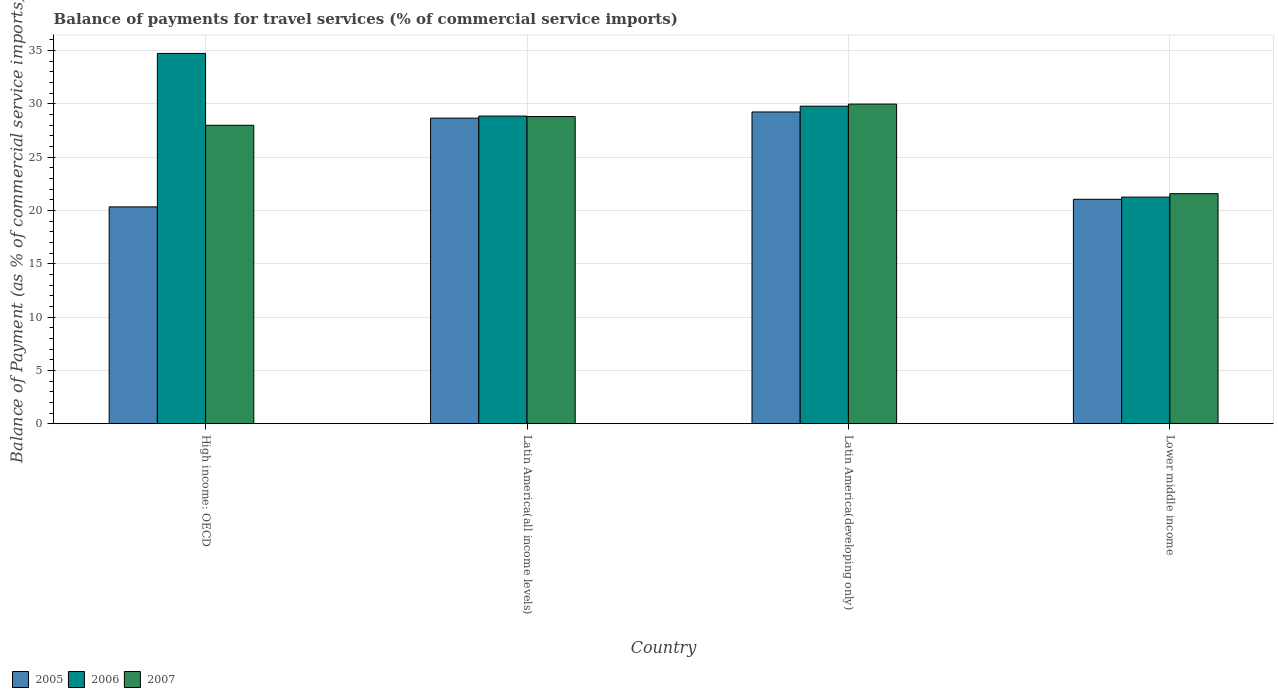How many different coloured bars are there?
Ensure brevity in your answer.  3. How many groups of bars are there?
Provide a succinct answer. 4. Are the number of bars per tick equal to the number of legend labels?
Make the answer very short. Yes. Are the number of bars on each tick of the X-axis equal?
Your answer should be compact. Yes. What is the label of the 4th group of bars from the left?
Provide a short and direct response. Lower middle income. In how many cases, is the number of bars for a given country not equal to the number of legend labels?
Your response must be concise. 0. What is the balance of payments for travel services in 2006 in Lower middle income?
Make the answer very short. 21.25. Across all countries, what is the maximum balance of payments for travel services in 2005?
Offer a terse response. 29.23. Across all countries, what is the minimum balance of payments for travel services in 2007?
Your answer should be very brief. 21.57. In which country was the balance of payments for travel services in 2006 maximum?
Make the answer very short. High income: OECD. In which country was the balance of payments for travel services in 2006 minimum?
Offer a terse response. Lower middle income. What is the total balance of payments for travel services in 2006 in the graph?
Provide a succinct answer. 114.58. What is the difference between the balance of payments for travel services in 2007 in High income: OECD and that in Latin America(all income levels)?
Give a very brief answer. -0.82. What is the difference between the balance of payments for travel services in 2007 in High income: OECD and the balance of payments for travel services in 2005 in Latin America(all income levels)?
Provide a succinct answer. -0.67. What is the average balance of payments for travel services in 2007 per country?
Make the answer very short. 27.08. What is the difference between the balance of payments for travel services of/in 2007 and balance of payments for travel services of/in 2005 in High income: OECD?
Make the answer very short. 7.65. In how many countries, is the balance of payments for travel services in 2006 greater than 35 %?
Provide a succinct answer. 0. What is the ratio of the balance of payments for travel services in 2007 in Latin America(all income levels) to that in Latin America(developing only)?
Make the answer very short. 0.96. Is the difference between the balance of payments for travel services in 2007 in Latin America(all income levels) and Lower middle income greater than the difference between the balance of payments for travel services in 2005 in Latin America(all income levels) and Lower middle income?
Keep it short and to the point. No. What is the difference between the highest and the second highest balance of payments for travel services in 2007?
Offer a terse response. -0.82. What is the difference between the highest and the lowest balance of payments for travel services in 2007?
Give a very brief answer. 8.4. What does the 1st bar from the right in High income: OECD represents?
Give a very brief answer. 2007. How many countries are there in the graph?
Ensure brevity in your answer.  4. What is the difference between two consecutive major ticks on the Y-axis?
Your response must be concise. 5. Are the values on the major ticks of Y-axis written in scientific E-notation?
Keep it short and to the point. No. Where does the legend appear in the graph?
Your response must be concise. Bottom left. How many legend labels are there?
Provide a short and direct response. 3. What is the title of the graph?
Your answer should be compact. Balance of payments for travel services (% of commercial service imports). What is the label or title of the X-axis?
Ensure brevity in your answer.  Country. What is the label or title of the Y-axis?
Provide a short and direct response. Balance of Payment (as % of commercial service imports). What is the Balance of Payment (as % of commercial service imports) in 2005 in High income: OECD?
Provide a succinct answer. 20.33. What is the Balance of Payment (as % of commercial service imports) in 2006 in High income: OECD?
Provide a short and direct response. 34.72. What is the Balance of Payment (as % of commercial service imports) in 2007 in High income: OECD?
Provide a short and direct response. 27.98. What is the Balance of Payment (as % of commercial service imports) in 2005 in Latin America(all income levels)?
Your answer should be compact. 28.65. What is the Balance of Payment (as % of commercial service imports) in 2006 in Latin America(all income levels)?
Your answer should be very brief. 28.84. What is the Balance of Payment (as % of commercial service imports) in 2007 in Latin America(all income levels)?
Offer a terse response. 28.8. What is the Balance of Payment (as % of commercial service imports) in 2005 in Latin America(developing only)?
Provide a succinct answer. 29.23. What is the Balance of Payment (as % of commercial service imports) of 2006 in Latin America(developing only)?
Ensure brevity in your answer.  29.77. What is the Balance of Payment (as % of commercial service imports) of 2007 in Latin America(developing only)?
Keep it short and to the point. 29.97. What is the Balance of Payment (as % of commercial service imports) in 2005 in Lower middle income?
Offer a terse response. 21.04. What is the Balance of Payment (as % of commercial service imports) of 2006 in Lower middle income?
Your answer should be very brief. 21.25. What is the Balance of Payment (as % of commercial service imports) of 2007 in Lower middle income?
Provide a succinct answer. 21.57. Across all countries, what is the maximum Balance of Payment (as % of commercial service imports) in 2005?
Offer a very short reply. 29.23. Across all countries, what is the maximum Balance of Payment (as % of commercial service imports) in 2006?
Give a very brief answer. 34.72. Across all countries, what is the maximum Balance of Payment (as % of commercial service imports) of 2007?
Ensure brevity in your answer.  29.97. Across all countries, what is the minimum Balance of Payment (as % of commercial service imports) of 2005?
Provide a succinct answer. 20.33. Across all countries, what is the minimum Balance of Payment (as % of commercial service imports) in 2006?
Your answer should be compact. 21.25. Across all countries, what is the minimum Balance of Payment (as % of commercial service imports) of 2007?
Offer a terse response. 21.57. What is the total Balance of Payment (as % of commercial service imports) in 2005 in the graph?
Offer a terse response. 99.25. What is the total Balance of Payment (as % of commercial service imports) of 2006 in the graph?
Provide a short and direct response. 114.58. What is the total Balance of Payment (as % of commercial service imports) of 2007 in the graph?
Make the answer very short. 108.31. What is the difference between the Balance of Payment (as % of commercial service imports) of 2005 in High income: OECD and that in Latin America(all income levels)?
Your response must be concise. -8.32. What is the difference between the Balance of Payment (as % of commercial service imports) in 2006 in High income: OECD and that in Latin America(all income levels)?
Make the answer very short. 5.88. What is the difference between the Balance of Payment (as % of commercial service imports) of 2007 in High income: OECD and that in Latin America(all income levels)?
Keep it short and to the point. -0.82. What is the difference between the Balance of Payment (as % of commercial service imports) in 2005 in High income: OECD and that in Latin America(developing only)?
Offer a very short reply. -8.9. What is the difference between the Balance of Payment (as % of commercial service imports) in 2006 in High income: OECD and that in Latin America(developing only)?
Your response must be concise. 4.95. What is the difference between the Balance of Payment (as % of commercial service imports) in 2007 in High income: OECD and that in Latin America(developing only)?
Provide a succinct answer. -1.99. What is the difference between the Balance of Payment (as % of commercial service imports) of 2005 in High income: OECD and that in Lower middle income?
Your answer should be very brief. -0.71. What is the difference between the Balance of Payment (as % of commercial service imports) in 2006 in High income: OECD and that in Lower middle income?
Your answer should be very brief. 13.47. What is the difference between the Balance of Payment (as % of commercial service imports) in 2007 in High income: OECD and that in Lower middle income?
Make the answer very short. 6.41. What is the difference between the Balance of Payment (as % of commercial service imports) in 2005 in Latin America(all income levels) and that in Latin America(developing only)?
Your response must be concise. -0.58. What is the difference between the Balance of Payment (as % of commercial service imports) in 2006 in Latin America(all income levels) and that in Latin America(developing only)?
Your answer should be very brief. -0.93. What is the difference between the Balance of Payment (as % of commercial service imports) in 2007 in Latin America(all income levels) and that in Latin America(developing only)?
Keep it short and to the point. -1.17. What is the difference between the Balance of Payment (as % of commercial service imports) in 2005 in Latin America(all income levels) and that in Lower middle income?
Offer a very short reply. 7.61. What is the difference between the Balance of Payment (as % of commercial service imports) in 2006 in Latin America(all income levels) and that in Lower middle income?
Make the answer very short. 7.6. What is the difference between the Balance of Payment (as % of commercial service imports) in 2007 in Latin America(all income levels) and that in Lower middle income?
Your answer should be very brief. 7.23. What is the difference between the Balance of Payment (as % of commercial service imports) in 2005 in Latin America(developing only) and that in Lower middle income?
Keep it short and to the point. 8.19. What is the difference between the Balance of Payment (as % of commercial service imports) of 2006 in Latin America(developing only) and that in Lower middle income?
Make the answer very short. 8.53. What is the difference between the Balance of Payment (as % of commercial service imports) of 2007 in Latin America(developing only) and that in Lower middle income?
Your response must be concise. 8.4. What is the difference between the Balance of Payment (as % of commercial service imports) in 2005 in High income: OECD and the Balance of Payment (as % of commercial service imports) in 2006 in Latin America(all income levels)?
Offer a terse response. -8.51. What is the difference between the Balance of Payment (as % of commercial service imports) in 2005 in High income: OECD and the Balance of Payment (as % of commercial service imports) in 2007 in Latin America(all income levels)?
Keep it short and to the point. -8.47. What is the difference between the Balance of Payment (as % of commercial service imports) of 2006 in High income: OECD and the Balance of Payment (as % of commercial service imports) of 2007 in Latin America(all income levels)?
Provide a succinct answer. 5.92. What is the difference between the Balance of Payment (as % of commercial service imports) in 2005 in High income: OECD and the Balance of Payment (as % of commercial service imports) in 2006 in Latin America(developing only)?
Provide a succinct answer. -9.44. What is the difference between the Balance of Payment (as % of commercial service imports) in 2005 in High income: OECD and the Balance of Payment (as % of commercial service imports) in 2007 in Latin America(developing only)?
Your answer should be compact. -9.64. What is the difference between the Balance of Payment (as % of commercial service imports) of 2006 in High income: OECD and the Balance of Payment (as % of commercial service imports) of 2007 in Latin America(developing only)?
Provide a succinct answer. 4.75. What is the difference between the Balance of Payment (as % of commercial service imports) in 2005 in High income: OECD and the Balance of Payment (as % of commercial service imports) in 2006 in Lower middle income?
Offer a terse response. -0.92. What is the difference between the Balance of Payment (as % of commercial service imports) of 2005 in High income: OECD and the Balance of Payment (as % of commercial service imports) of 2007 in Lower middle income?
Give a very brief answer. -1.24. What is the difference between the Balance of Payment (as % of commercial service imports) in 2006 in High income: OECD and the Balance of Payment (as % of commercial service imports) in 2007 in Lower middle income?
Offer a very short reply. 13.15. What is the difference between the Balance of Payment (as % of commercial service imports) of 2005 in Latin America(all income levels) and the Balance of Payment (as % of commercial service imports) of 2006 in Latin America(developing only)?
Your answer should be very brief. -1.12. What is the difference between the Balance of Payment (as % of commercial service imports) in 2005 in Latin America(all income levels) and the Balance of Payment (as % of commercial service imports) in 2007 in Latin America(developing only)?
Offer a terse response. -1.32. What is the difference between the Balance of Payment (as % of commercial service imports) of 2006 in Latin America(all income levels) and the Balance of Payment (as % of commercial service imports) of 2007 in Latin America(developing only)?
Offer a terse response. -1.12. What is the difference between the Balance of Payment (as % of commercial service imports) of 2005 in Latin America(all income levels) and the Balance of Payment (as % of commercial service imports) of 2006 in Lower middle income?
Offer a very short reply. 7.4. What is the difference between the Balance of Payment (as % of commercial service imports) of 2005 in Latin America(all income levels) and the Balance of Payment (as % of commercial service imports) of 2007 in Lower middle income?
Your answer should be compact. 7.08. What is the difference between the Balance of Payment (as % of commercial service imports) in 2006 in Latin America(all income levels) and the Balance of Payment (as % of commercial service imports) in 2007 in Lower middle income?
Make the answer very short. 7.28. What is the difference between the Balance of Payment (as % of commercial service imports) in 2005 in Latin America(developing only) and the Balance of Payment (as % of commercial service imports) in 2006 in Lower middle income?
Keep it short and to the point. 7.98. What is the difference between the Balance of Payment (as % of commercial service imports) of 2005 in Latin America(developing only) and the Balance of Payment (as % of commercial service imports) of 2007 in Lower middle income?
Offer a very short reply. 7.66. What is the difference between the Balance of Payment (as % of commercial service imports) of 2006 in Latin America(developing only) and the Balance of Payment (as % of commercial service imports) of 2007 in Lower middle income?
Offer a very short reply. 8.2. What is the average Balance of Payment (as % of commercial service imports) in 2005 per country?
Provide a short and direct response. 24.81. What is the average Balance of Payment (as % of commercial service imports) in 2006 per country?
Your response must be concise. 28.65. What is the average Balance of Payment (as % of commercial service imports) of 2007 per country?
Offer a terse response. 27.08. What is the difference between the Balance of Payment (as % of commercial service imports) in 2005 and Balance of Payment (as % of commercial service imports) in 2006 in High income: OECD?
Your answer should be compact. -14.39. What is the difference between the Balance of Payment (as % of commercial service imports) in 2005 and Balance of Payment (as % of commercial service imports) in 2007 in High income: OECD?
Your answer should be compact. -7.65. What is the difference between the Balance of Payment (as % of commercial service imports) in 2006 and Balance of Payment (as % of commercial service imports) in 2007 in High income: OECD?
Offer a very short reply. 6.74. What is the difference between the Balance of Payment (as % of commercial service imports) of 2005 and Balance of Payment (as % of commercial service imports) of 2006 in Latin America(all income levels)?
Ensure brevity in your answer.  -0.19. What is the difference between the Balance of Payment (as % of commercial service imports) of 2005 and Balance of Payment (as % of commercial service imports) of 2007 in Latin America(all income levels)?
Your answer should be compact. -0.15. What is the difference between the Balance of Payment (as % of commercial service imports) in 2006 and Balance of Payment (as % of commercial service imports) in 2007 in Latin America(all income levels)?
Keep it short and to the point. 0.04. What is the difference between the Balance of Payment (as % of commercial service imports) of 2005 and Balance of Payment (as % of commercial service imports) of 2006 in Latin America(developing only)?
Your answer should be very brief. -0.54. What is the difference between the Balance of Payment (as % of commercial service imports) of 2005 and Balance of Payment (as % of commercial service imports) of 2007 in Latin America(developing only)?
Your answer should be very brief. -0.74. What is the difference between the Balance of Payment (as % of commercial service imports) of 2006 and Balance of Payment (as % of commercial service imports) of 2007 in Latin America(developing only)?
Keep it short and to the point. -0.2. What is the difference between the Balance of Payment (as % of commercial service imports) of 2005 and Balance of Payment (as % of commercial service imports) of 2006 in Lower middle income?
Your answer should be very brief. -0.2. What is the difference between the Balance of Payment (as % of commercial service imports) of 2005 and Balance of Payment (as % of commercial service imports) of 2007 in Lower middle income?
Make the answer very short. -0.53. What is the difference between the Balance of Payment (as % of commercial service imports) in 2006 and Balance of Payment (as % of commercial service imports) in 2007 in Lower middle income?
Your response must be concise. -0.32. What is the ratio of the Balance of Payment (as % of commercial service imports) in 2005 in High income: OECD to that in Latin America(all income levels)?
Your response must be concise. 0.71. What is the ratio of the Balance of Payment (as % of commercial service imports) of 2006 in High income: OECD to that in Latin America(all income levels)?
Ensure brevity in your answer.  1.2. What is the ratio of the Balance of Payment (as % of commercial service imports) of 2007 in High income: OECD to that in Latin America(all income levels)?
Your answer should be very brief. 0.97. What is the ratio of the Balance of Payment (as % of commercial service imports) of 2005 in High income: OECD to that in Latin America(developing only)?
Keep it short and to the point. 0.7. What is the ratio of the Balance of Payment (as % of commercial service imports) in 2006 in High income: OECD to that in Latin America(developing only)?
Make the answer very short. 1.17. What is the ratio of the Balance of Payment (as % of commercial service imports) in 2007 in High income: OECD to that in Latin America(developing only)?
Your answer should be compact. 0.93. What is the ratio of the Balance of Payment (as % of commercial service imports) in 2005 in High income: OECD to that in Lower middle income?
Keep it short and to the point. 0.97. What is the ratio of the Balance of Payment (as % of commercial service imports) of 2006 in High income: OECD to that in Lower middle income?
Provide a succinct answer. 1.63. What is the ratio of the Balance of Payment (as % of commercial service imports) in 2007 in High income: OECD to that in Lower middle income?
Your answer should be compact. 1.3. What is the ratio of the Balance of Payment (as % of commercial service imports) in 2005 in Latin America(all income levels) to that in Latin America(developing only)?
Provide a succinct answer. 0.98. What is the ratio of the Balance of Payment (as % of commercial service imports) in 2006 in Latin America(all income levels) to that in Latin America(developing only)?
Your response must be concise. 0.97. What is the ratio of the Balance of Payment (as % of commercial service imports) of 2007 in Latin America(all income levels) to that in Latin America(developing only)?
Your answer should be very brief. 0.96. What is the ratio of the Balance of Payment (as % of commercial service imports) in 2005 in Latin America(all income levels) to that in Lower middle income?
Ensure brevity in your answer.  1.36. What is the ratio of the Balance of Payment (as % of commercial service imports) of 2006 in Latin America(all income levels) to that in Lower middle income?
Provide a short and direct response. 1.36. What is the ratio of the Balance of Payment (as % of commercial service imports) in 2007 in Latin America(all income levels) to that in Lower middle income?
Keep it short and to the point. 1.34. What is the ratio of the Balance of Payment (as % of commercial service imports) of 2005 in Latin America(developing only) to that in Lower middle income?
Your answer should be compact. 1.39. What is the ratio of the Balance of Payment (as % of commercial service imports) in 2006 in Latin America(developing only) to that in Lower middle income?
Your answer should be compact. 1.4. What is the ratio of the Balance of Payment (as % of commercial service imports) in 2007 in Latin America(developing only) to that in Lower middle income?
Provide a succinct answer. 1.39. What is the difference between the highest and the second highest Balance of Payment (as % of commercial service imports) of 2005?
Your answer should be very brief. 0.58. What is the difference between the highest and the second highest Balance of Payment (as % of commercial service imports) of 2006?
Make the answer very short. 4.95. What is the difference between the highest and the second highest Balance of Payment (as % of commercial service imports) of 2007?
Provide a short and direct response. 1.17. What is the difference between the highest and the lowest Balance of Payment (as % of commercial service imports) of 2005?
Offer a very short reply. 8.9. What is the difference between the highest and the lowest Balance of Payment (as % of commercial service imports) in 2006?
Offer a very short reply. 13.47. What is the difference between the highest and the lowest Balance of Payment (as % of commercial service imports) in 2007?
Make the answer very short. 8.4. 